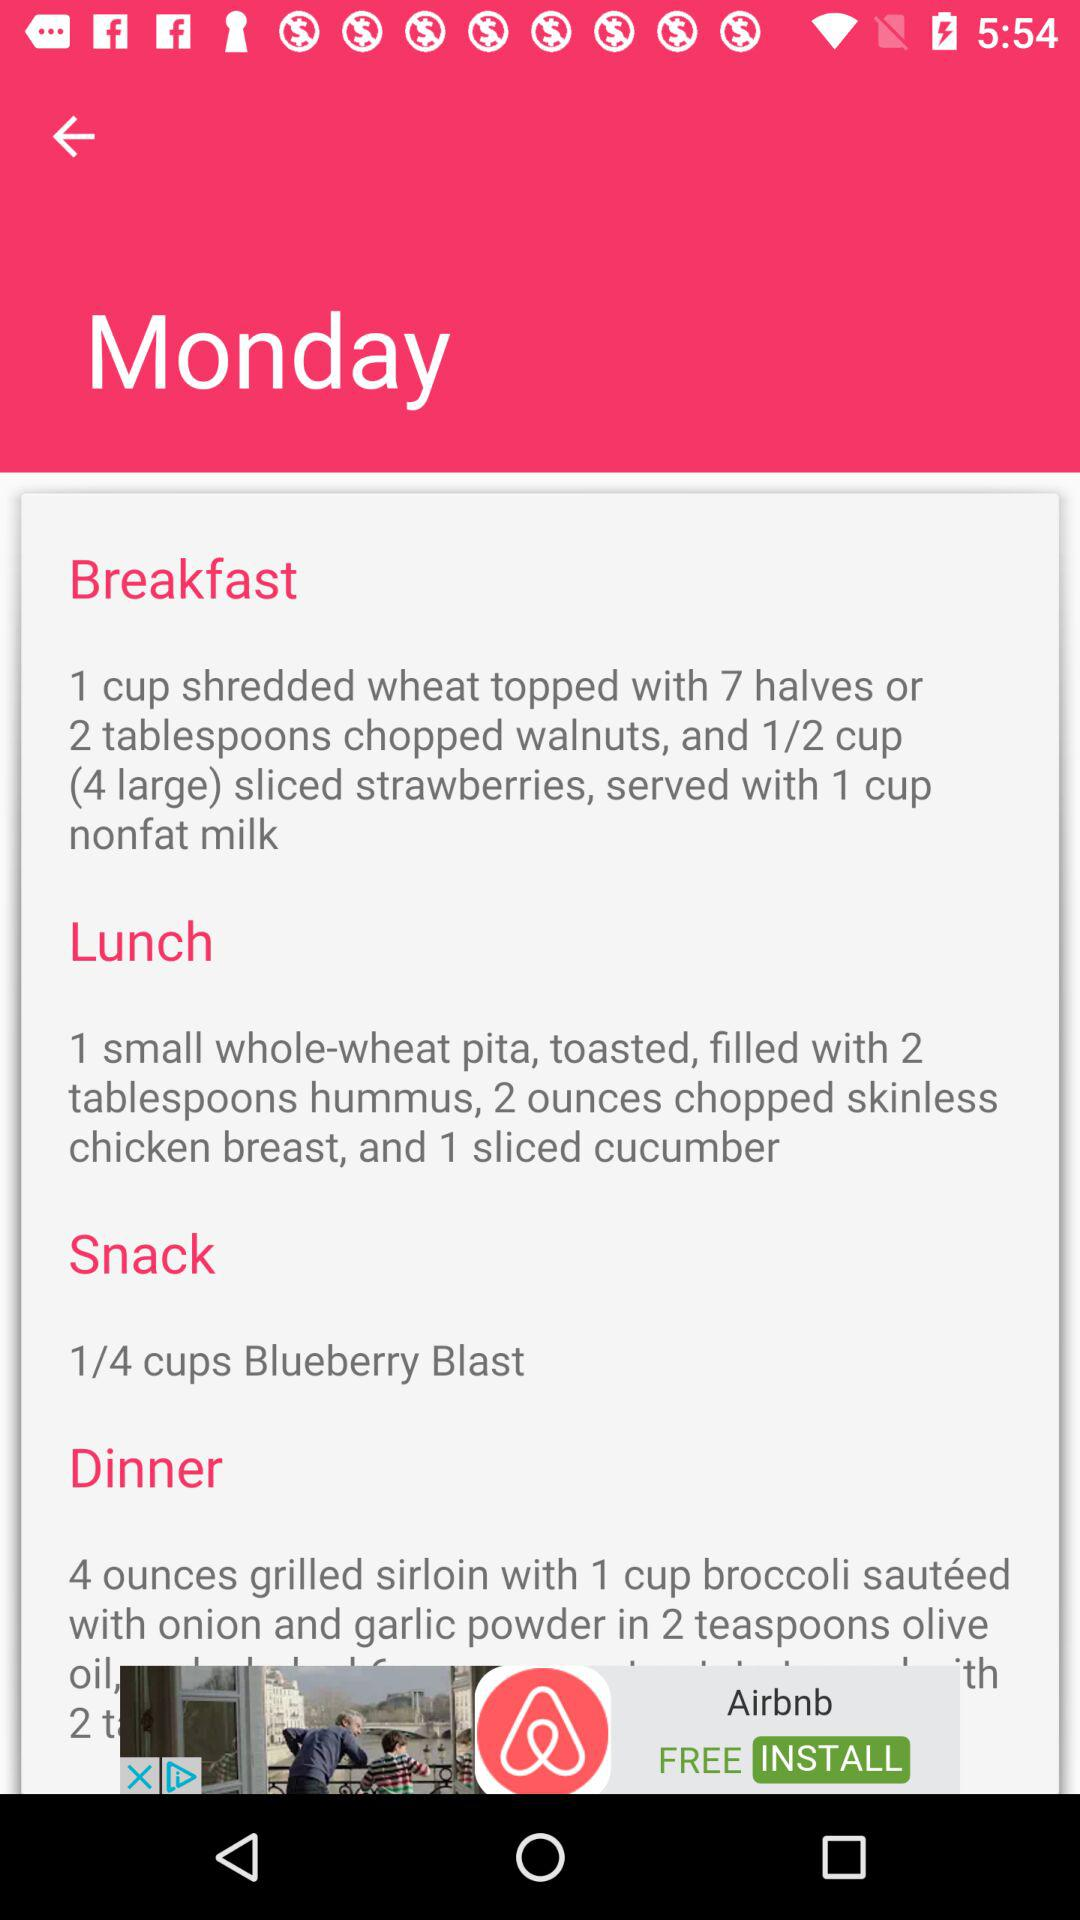How many ingredients are needed for dessert?
When the provided information is insufficient, respond with <no answer>. <no answer> 